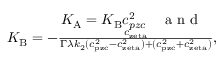<formula> <loc_0><loc_0><loc_500><loc_500>\begin{array} { r } { K _ { A } = K _ { B } c _ { p z c } ^ { 2 } \quad a n d \quad } \\ { K _ { B } = - \frac { c _ { z e t a } } { \Gamma \lambda k _ { 2 } ( c _ { p z c } ^ { 2 } - c _ { z e t a } ^ { 2 } ) + ( c _ { p z c } ^ { 2 } + c _ { z e t a } ^ { 2 } ) } , } \end{array}</formula> 